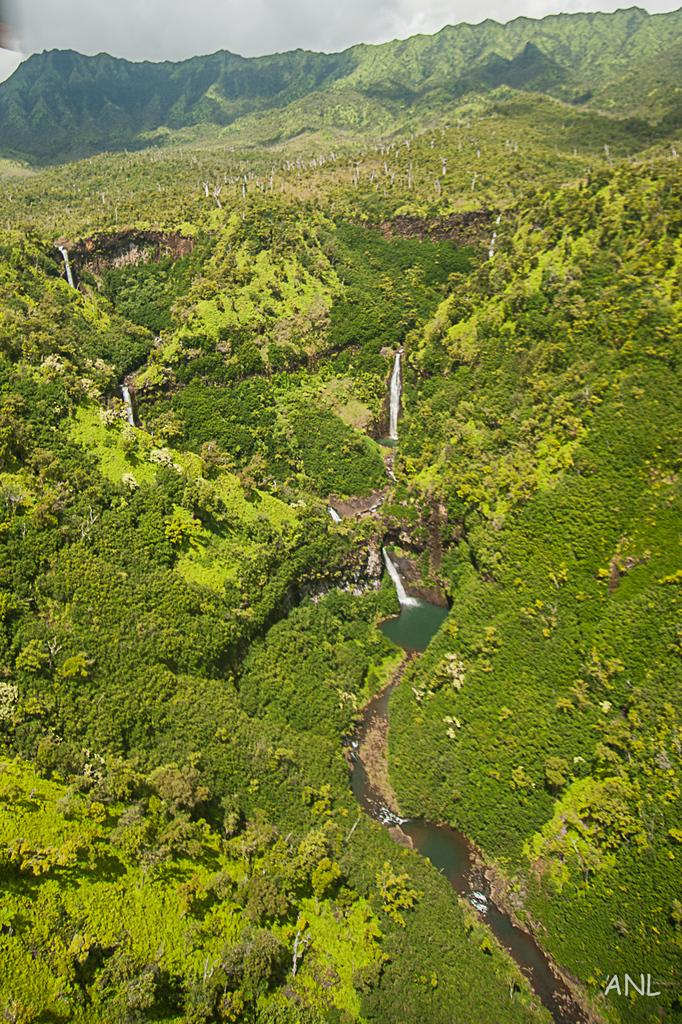What is the primary element visible in the image? There is water in the image. What type of natural vegetation can be seen in the image? There are trees in the image. Is there any indication of the image's origin or ownership? Yes, there is a watermark in the image. Can you tell me where the writer is sitting in the image? There is no writer present in the image; it only features water and trees. 